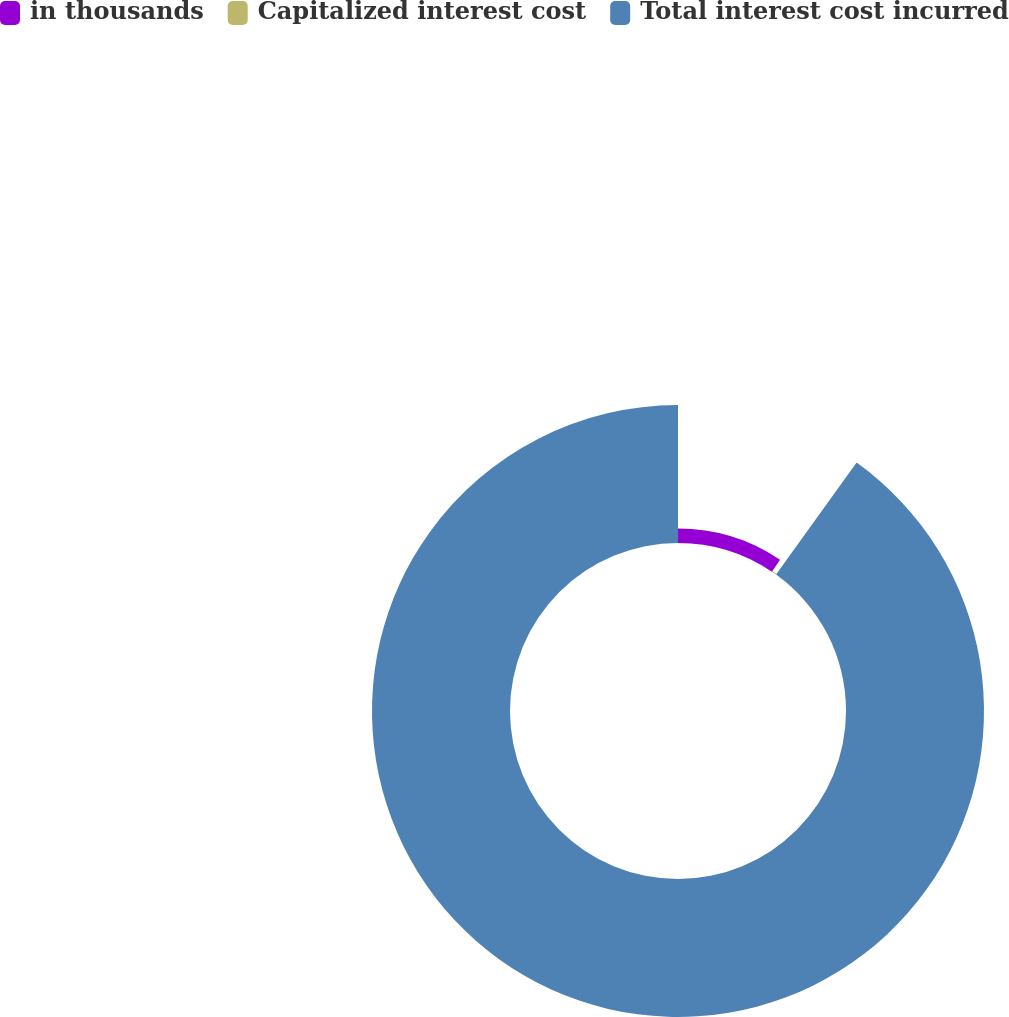<chart> <loc_0><loc_0><loc_500><loc_500><pie_chart><fcel>in thousands<fcel>Capitalized interest cost<fcel>Total interest cost incurred<nl><fcel>9.44%<fcel>0.48%<fcel>90.08%<nl></chart> 